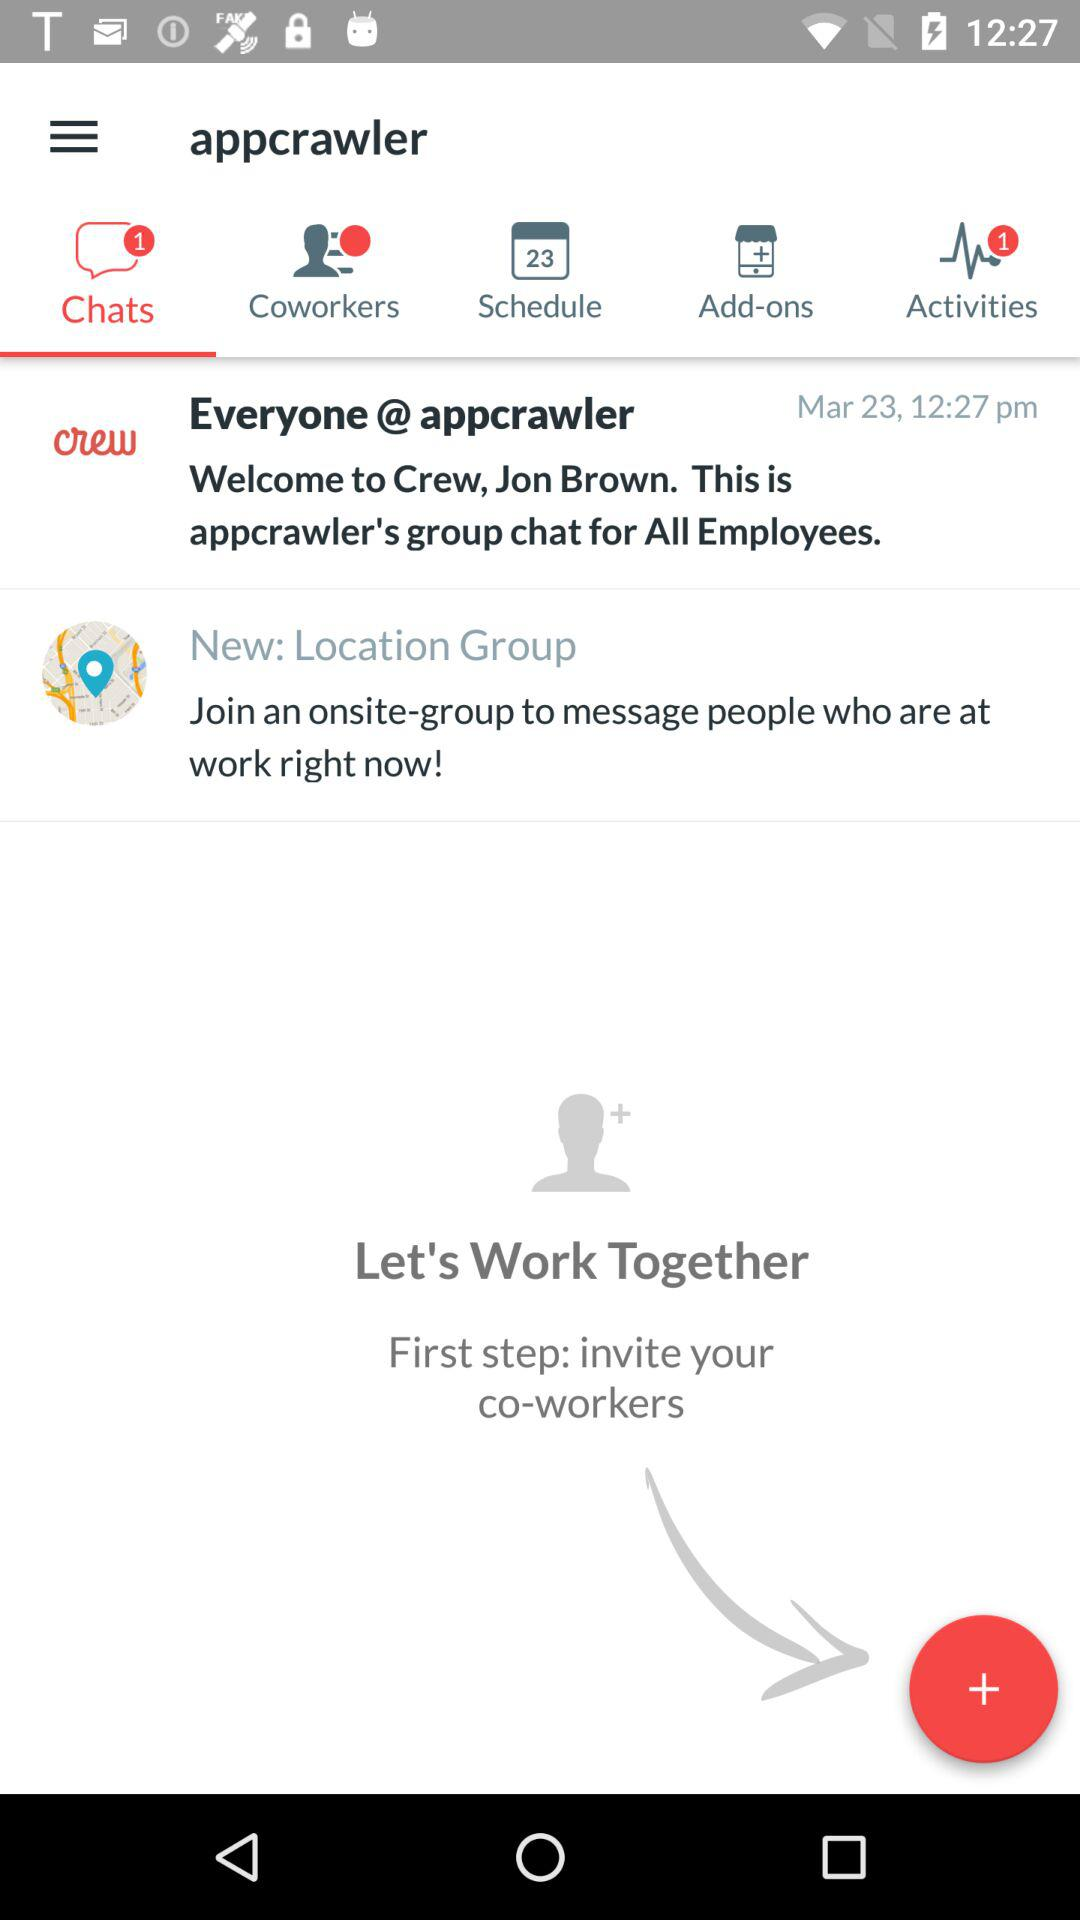What is the total number of unread chats? The total number of unread chats is 1. 